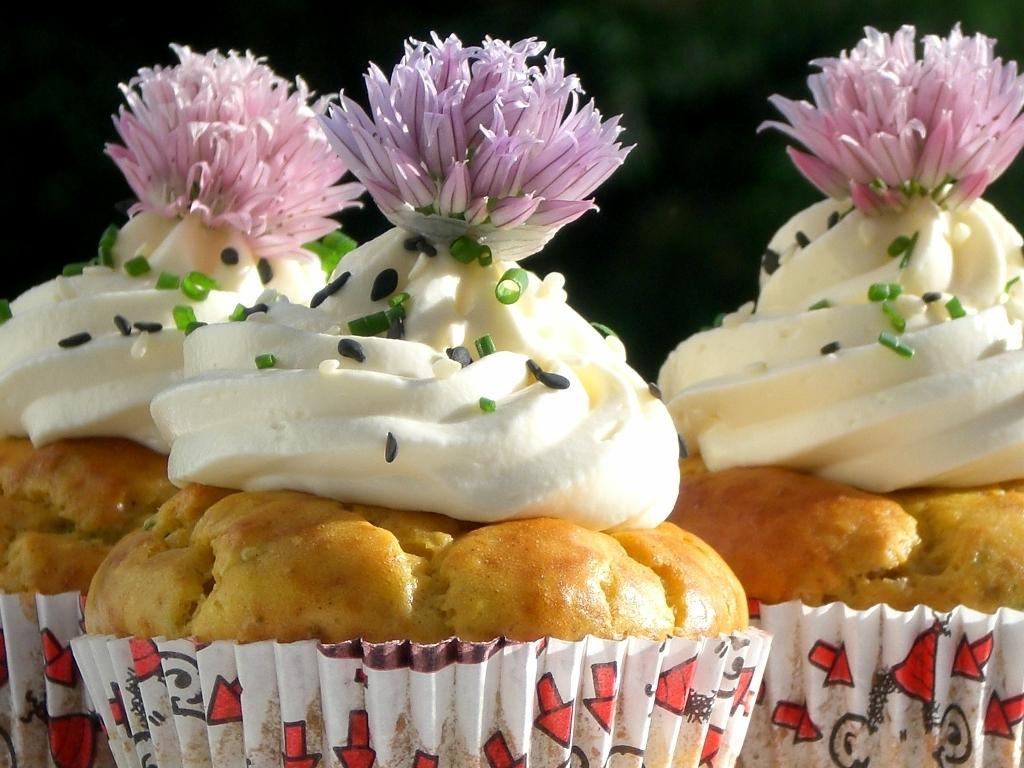What is the visual effect on the background of the image? The background portion of the picture is blurred. What type of food is featured in the image? There are cupcakes in the image. How are the cupcakes decorated? The cupcakes are garnished with flowers, sesame seeds, and spring onions. How does the wind affect the team's performance in the image? There is no reference to a team or wind in the image, as it features cupcakes with various garnishes. 